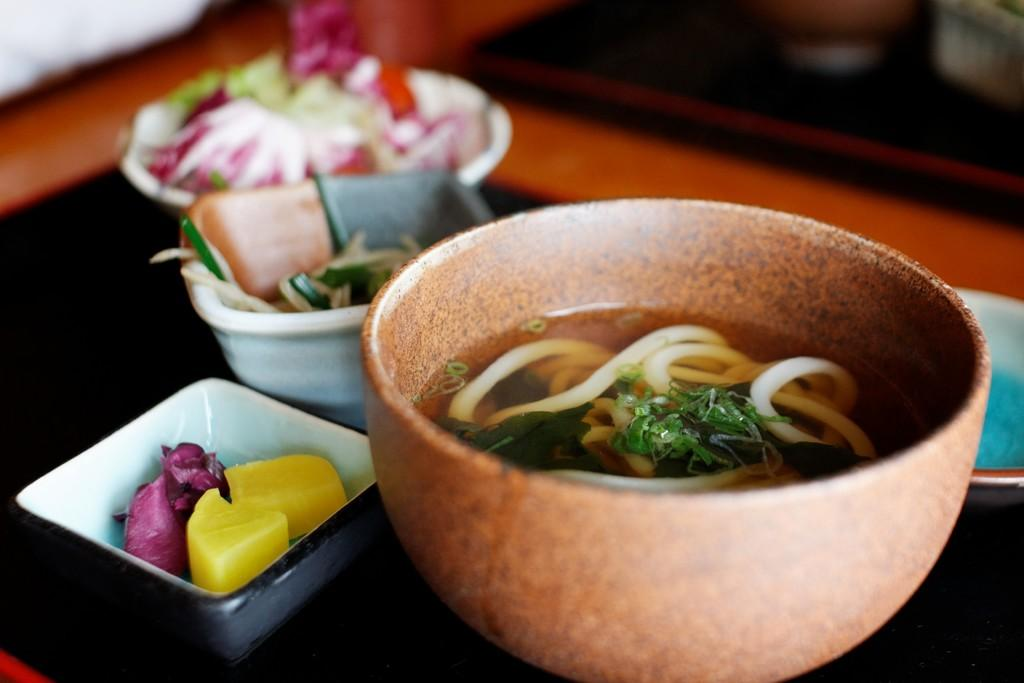What is the main piece of furniture in the image? There is a table in the image. What is placed on the table? There are bowls with food on the table. What is the price of the parcel in the image? There is no parcel present in the image, so it is not possible to determine its price. 